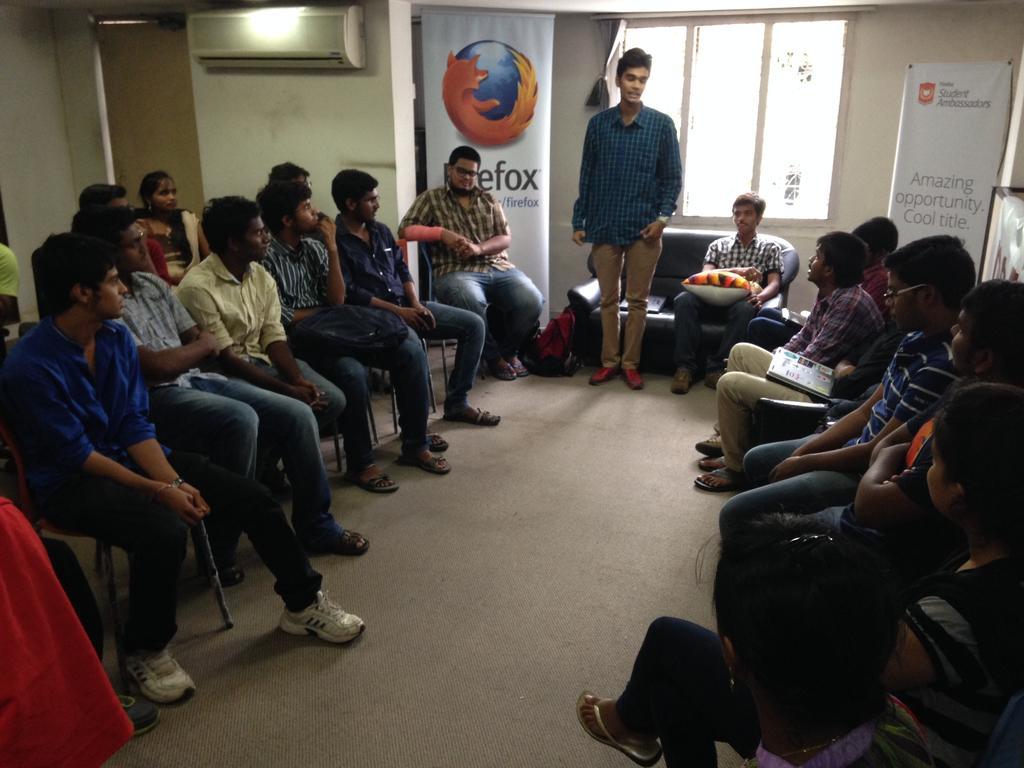Please provide a concise description of this image. In this picture there is a group of boys sitting on the chairs and listening. In the front side there is a boy wearing blue color shirt delivering a speech. In the background we can see a white color rolling banner and big window. On the left side there is a white wall and a Ac unit on the top. 